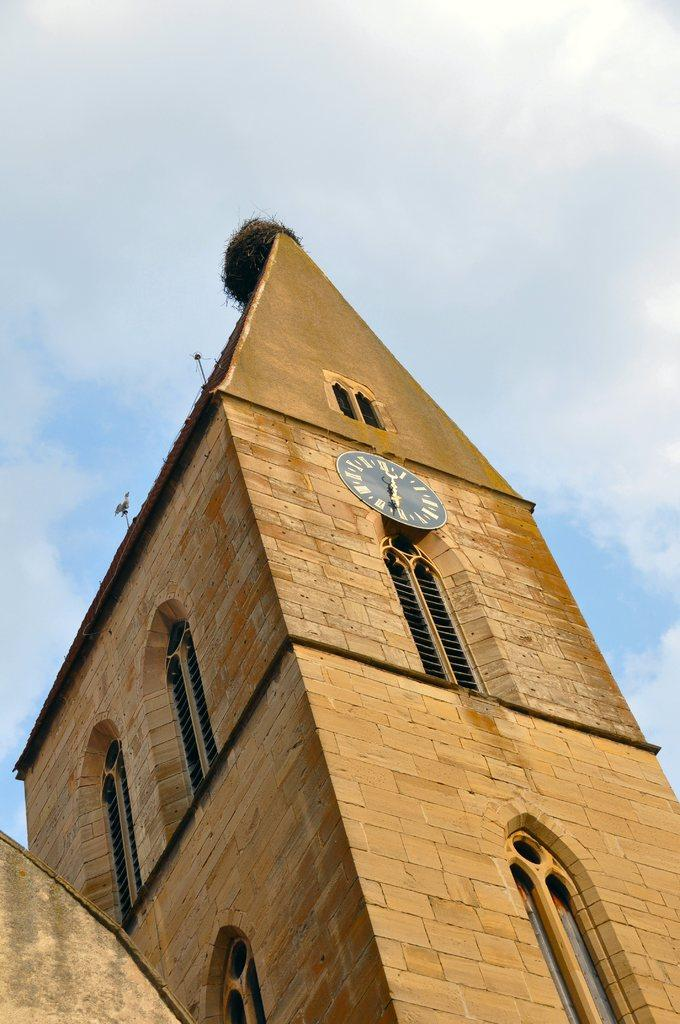What is the main structure in the middle of the image? There is a building in the middle of the image. Are there any objects near the building? Yes, there is a wall clock near the building. What can be seen at the top of the image? The sky is visible at the top of the image. What feature can be observed on the building? There are windows on the building. How many lizards are crawling on the wall clock in the image? There are no lizards present in the image, and therefore no such activity can be observed. 